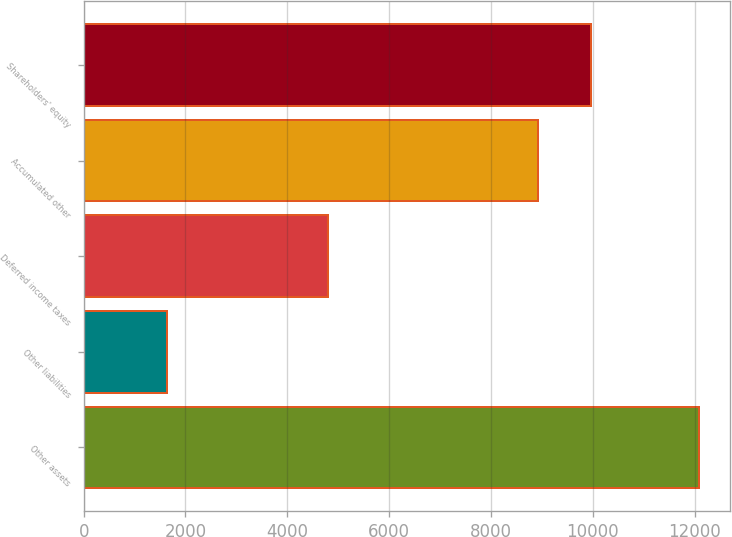<chart> <loc_0><loc_0><loc_500><loc_500><bar_chart><fcel>Other assets<fcel>Other liabilities<fcel>Deferred income taxes<fcel>Accumulated other<fcel>Shareholders' equity<nl><fcel>12083<fcel>1632<fcel>4800<fcel>8915<fcel>9960.1<nl></chart> 